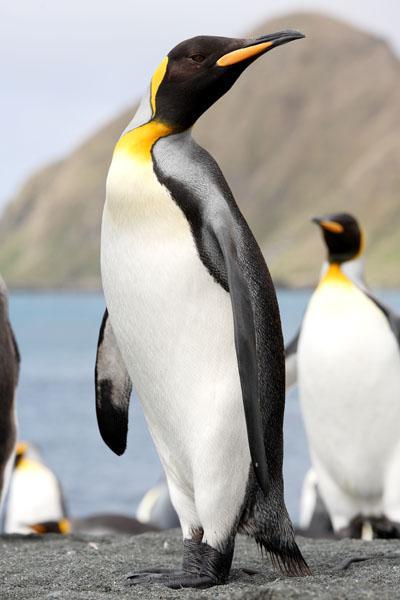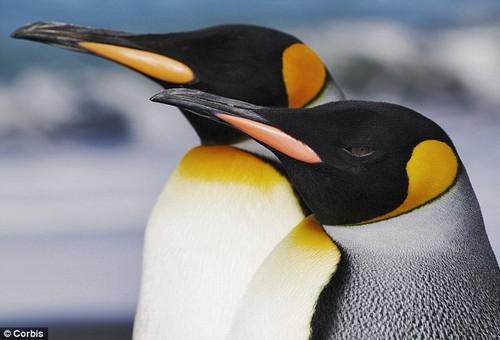The first image is the image on the left, the second image is the image on the right. Analyze the images presented: Is the assertion "At least one image contains only two penguins facing each other." valid? Answer yes or no. No. 